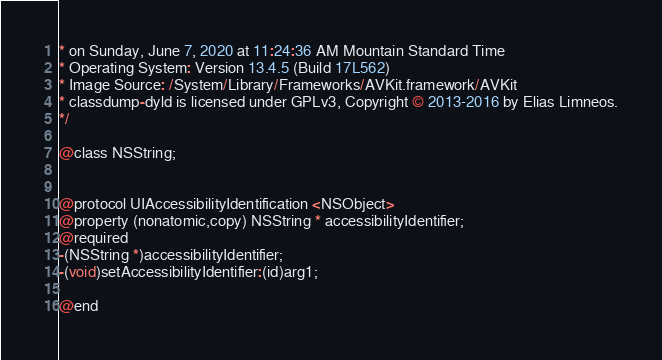Convert code to text. <code><loc_0><loc_0><loc_500><loc_500><_C_>* on Sunday, June 7, 2020 at 11:24:36 AM Mountain Standard Time
* Operating System: Version 13.4.5 (Build 17L562)
* Image Source: /System/Library/Frameworks/AVKit.framework/AVKit
* classdump-dyld is licensed under GPLv3, Copyright © 2013-2016 by Elias Limneos.
*/

@class NSString;


@protocol UIAccessibilityIdentification <NSObject>
@property (nonatomic,copy) NSString * accessibilityIdentifier; 
@required
-(NSString *)accessibilityIdentifier;
-(void)setAccessibilityIdentifier:(id)arg1;

@end

</code> 